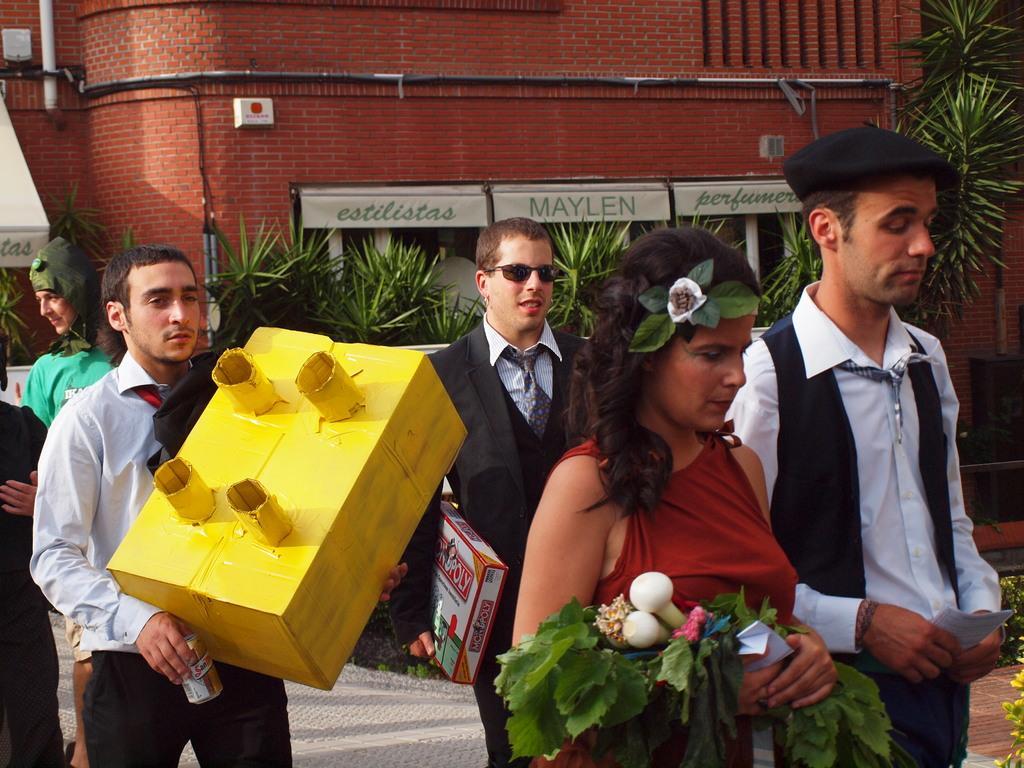Please provide a concise description of this image. In the middle of the image few people are walking and holding some boxes, papers and leaves. Behind them we can see some plants and buildings. 